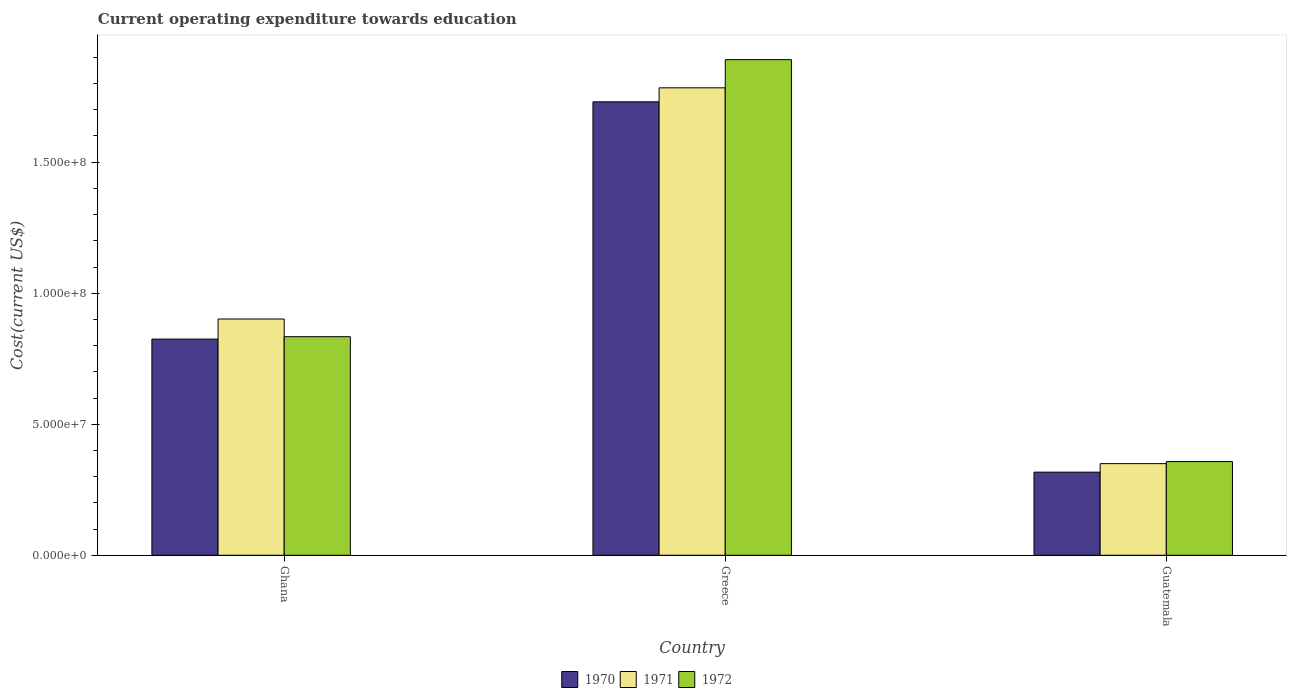How many different coloured bars are there?
Give a very brief answer. 3. How many groups of bars are there?
Offer a very short reply. 3. Are the number of bars per tick equal to the number of legend labels?
Your response must be concise. Yes. Are the number of bars on each tick of the X-axis equal?
Provide a succinct answer. Yes. What is the expenditure towards education in 1971 in Ghana?
Ensure brevity in your answer.  9.02e+07. Across all countries, what is the maximum expenditure towards education in 1971?
Ensure brevity in your answer.  1.78e+08. Across all countries, what is the minimum expenditure towards education in 1971?
Offer a very short reply. 3.50e+07. In which country was the expenditure towards education in 1970 minimum?
Give a very brief answer. Guatemala. What is the total expenditure towards education in 1972 in the graph?
Your answer should be compact. 3.08e+08. What is the difference between the expenditure towards education in 1972 in Greece and that in Guatemala?
Make the answer very short. 1.53e+08. What is the difference between the expenditure towards education in 1972 in Ghana and the expenditure towards education in 1971 in Guatemala?
Offer a terse response. 4.84e+07. What is the average expenditure towards education in 1970 per country?
Your answer should be very brief. 9.57e+07. What is the difference between the expenditure towards education of/in 1970 and expenditure towards education of/in 1972 in Ghana?
Your answer should be very brief. -9.19e+05. What is the ratio of the expenditure towards education in 1972 in Ghana to that in Greece?
Offer a very short reply. 0.44. Is the difference between the expenditure towards education in 1970 in Ghana and Guatemala greater than the difference between the expenditure towards education in 1972 in Ghana and Guatemala?
Your answer should be compact. Yes. What is the difference between the highest and the second highest expenditure towards education in 1972?
Make the answer very short. 4.76e+07. What is the difference between the highest and the lowest expenditure towards education in 1971?
Your answer should be compact. 1.43e+08. In how many countries, is the expenditure towards education in 1972 greater than the average expenditure towards education in 1972 taken over all countries?
Ensure brevity in your answer.  1. Is it the case that in every country, the sum of the expenditure towards education in 1970 and expenditure towards education in 1971 is greater than the expenditure towards education in 1972?
Make the answer very short. Yes. How many bars are there?
Keep it short and to the point. 9. Are all the bars in the graph horizontal?
Offer a very short reply. No. How many countries are there in the graph?
Provide a short and direct response. 3. What is the difference between two consecutive major ticks on the Y-axis?
Your response must be concise. 5.00e+07. Are the values on the major ticks of Y-axis written in scientific E-notation?
Offer a very short reply. Yes. Does the graph contain grids?
Offer a very short reply. No. Where does the legend appear in the graph?
Offer a terse response. Bottom center. What is the title of the graph?
Give a very brief answer. Current operating expenditure towards education. What is the label or title of the X-axis?
Your answer should be very brief. Country. What is the label or title of the Y-axis?
Keep it short and to the point. Cost(current US$). What is the Cost(current US$) in 1970 in Ghana?
Your response must be concise. 8.25e+07. What is the Cost(current US$) of 1971 in Ghana?
Provide a short and direct response. 9.02e+07. What is the Cost(current US$) in 1972 in Ghana?
Your answer should be compact. 8.34e+07. What is the Cost(current US$) in 1970 in Greece?
Provide a short and direct response. 1.73e+08. What is the Cost(current US$) of 1971 in Greece?
Ensure brevity in your answer.  1.78e+08. What is the Cost(current US$) of 1972 in Greece?
Your response must be concise. 1.89e+08. What is the Cost(current US$) in 1970 in Guatemala?
Your response must be concise. 3.17e+07. What is the Cost(current US$) in 1971 in Guatemala?
Make the answer very short. 3.50e+07. What is the Cost(current US$) in 1972 in Guatemala?
Offer a very short reply. 3.58e+07. Across all countries, what is the maximum Cost(current US$) of 1970?
Keep it short and to the point. 1.73e+08. Across all countries, what is the maximum Cost(current US$) in 1971?
Offer a terse response. 1.78e+08. Across all countries, what is the maximum Cost(current US$) in 1972?
Provide a short and direct response. 1.89e+08. Across all countries, what is the minimum Cost(current US$) of 1970?
Your response must be concise. 3.17e+07. Across all countries, what is the minimum Cost(current US$) in 1971?
Your answer should be very brief. 3.50e+07. Across all countries, what is the minimum Cost(current US$) of 1972?
Ensure brevity in your answer.  3.58e+07. What is the total Cost(current US$) in 1970 in the graph?
Offer a very short reply. 2.87e+08. What is the total Cost(current US$) in 1971 in the graph?
Provide a short and direct response. 3.04e+08. What is the total Cost(current US$) in 1972 in the graph?
Your answer should be compact. 3.08e+08. What is the difference between the Cost(current US$) in 1970 in Ghana and that in Greece?
Keep it short and to the point. -9.05e+07. What is the difference between the Cost(current US$) in 1971 in Ghana and that in Greece?
Ensure brevity in your answer.  -8.82e+07. What is the difference between the Cost(current US$) in 1972 in Ghana and that in Greece?
Your answer should be very brief. -1.06e+08. What is the difference between the Cost(current US$) in 1970 in Ghana and that in Guatemala?
Provide a succinct answer. 5.08e+07. What is the difference between the Cost(current US$) of 1971 in Ghana and that in Guatemala?
Your response must be concise. 5.52e+07. What is the difference between the Cost(current US$) in 1972 in Ghana and that in Guatemala?
Make the answer very short. 4.76e+07. What is the difference between the Cost(current US$) of 1970 in Greece and that in Guatemala?
Offer a very short reply. 1.41e+08. What is the difference between the Cost(current US$) in 1971 in Greece and that in Guatemala?
Make the answer very short. 1.43e+08. What is the difference between the Cost(current US$) of 1972 in Greece and that in Guatemala?
Your answer should be very brief. 1.53e+08. What is the difference between the Cost(current US$) in 1970 in Ghana and the Cost(current US$) in 1971 in Greece?
Provide a short and direct response. -9.59e+07. What is the difference between the Cost(current US$) in 1970 in Ghana and the Cost(current US$) in 1972 in Greece?
Provide a succinct answer. -1.07e+08. What is the difference between the Cost(current US$) of 1971 in Ghana and the Cost(current US$) of 1972 in Greece?
Offer a terse response. -9.90e+07. What is the difference between the Cost(current US$) of 1970 in Ghana and the Cost(current US$) of 1971 in Guatemala?
Provide a succinct answer. 4.75e+07. What is the difference between the Cost(current US$) of 1970 in Ghana and the Cost(current US$) of 1972 in Guatemala?
Your answer should be very brief. 4.67e+07. What is the difference between the Cost(current US$) in 1971 in Ghana and the Cost(current US$) in 1972 in Guatemala?
Offer a very short reply. 5.44e+07. What is the difference between the Cost(current US$) of 1970 in Greece and the Cost(current US$) of 1971 in Guatemala?
Keep it short and to the point. 1.38e+08. What is the difference between the Cost(current US$) of 1970 in Greece and the Cost(current US$) of 1972 in Guatemala?
Keep it short and to the point. 1.37e+08. What is the difference between the Cost(current US$) in 1971 in Greece and the Cost(current US$) in 1972 in Guatemala?
Ensure brevity in your answer.  1.43e+08. What is the average Cost(current US$) in 1970 per country?
Provide a short and direct response. 9.57e+07. What is the average Cost(current US$) in 1971 per country?
Your response must be concise. 1.01e+08. What is the average Cost(current US$) in 1972 per country?
Your answer should be compact. 1.03e+08. What is the difference between the Cost(current US$) of 1970 and Cost(current US$) of 1971 in Ghana?
Provide a succinct answer. -7.67e+06. What is the difference between the Cost(current US$) in 1970 and Cost(current US$) in 1972 in Ghana?
Your response must be concise. -9.19e+05. What is the difference between the Cost(current US$) of 1971 and Cost(current US$) of 1972 in Ghana?
Give a very brief answer. 6.75e+06. What is the difference between the Cost(current US$) of 1970 and Cost(current US$) of 1971 in Greece?
Your answer should be very brief. -5.34e+06. What is the difference between the Cost(current US$) of 1970 and Cost(current US$) of 1972 in Greece?
Keep it short and to the point. -1.61e+07. What is the difference between the Cost(current US$) in 1971 and Cost(current US$) in 1972 in Greece?
Your response must be concise. -1.07e+07. What is the difference between the Cost(current US$) of 1970 and Cost(current US$) of 1971 in Guatemala?
Make the answer very short. -3.25e+06. What is the difference between the Cost(current US$) of 1970 and Cost(current US$) of 1972 in Guatemala?
Offer a terse response. -4.05e+06. What is the difference between the Cost(current US$) of 1971 and Cost(current US$) of 1972 in Guatemala?
Your response must be concise. -7.97e+05. What is the ratio of the Cost(current US$) in 1970 in Ghana to that in Greece?
Make the answer very short. 0.48. What is the ratio of the Cost(current US$) in 1971 in Ghana to that in Greece?
Make the answer very short. 0.51. What is the ratio of the Cost(current US$) in 1972 in Ghana to that in Greece?
Provide a succinct answer. 0.44. What is the ratio of the Cost(current US$) of 1970 in Ghana to that in Guatemala?
Provide a short and direct response. 2.6. What is the ratio of the Cost(current US$) in 1971 in Ghana to that in Guatemala?
Your response must be concise. 2.58. What is the ratio of the Cost(current US$) in 1972 in Ghana to that in Guatemala?
Ensure brevity in your answer.  2.33. What is the ratio of the Cost(current US$) of 1970 in Greece to that in Guatemala?
Give a very brief answer. 5.46. What is the ratio of the Cost(current US$) in 1971 in Greece to that in Guatemala?
Give a very brief answer. 5.1. What is the ratio of the Cost(current US$) in 1972 in Greece to that in Guatemala?
Make the answer very short. 5.29. What is the difference between the highest and the second highest Cost(current US$) of 1970?
Keep it short and to the point. 9.05e+07. What is the difference between the highest and the second highest Cost(current US$) of 1971?
Give a very brief answer. 8.82e+07. What is the difference between the highest and the second highest Cost(current US$) of 1972?
Give a very brief answer. 1.06e+08. What is the difference between the highest and the lowest Cost(current US$) in 1970?
Make the answer very short. 1.41e+08. What is the difference between the highest and the lowest Cost(current US$) in 1971?
Provide a short and direct response. 1.43e+08. What is the difference between the highest and the lowest Cost(current US$) in 1972?
Provide a succinct answer. 1.53e+08. 